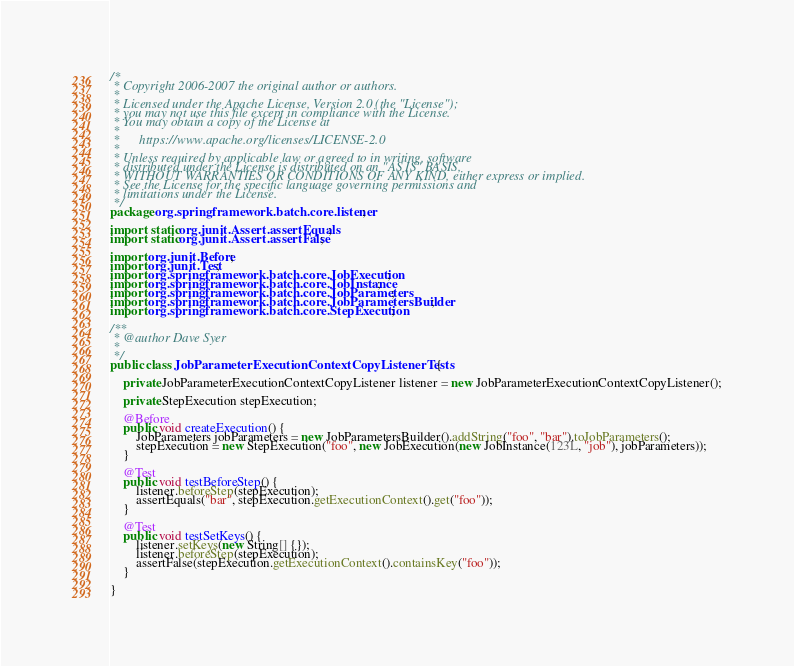<code> <loc_0><loc_0><loc_500><loc_500><_Java_>/*
 * Copyright 2006-2007 the original author or authors.
 *
 * Licensed under the Apache License, Version 2.0 (the "License");
 * you may not use this file except in compliance with the License.
 * You may obtain a copy of the License at
 *
 *      https://www.apache.org/licenses/LICENSE-2.0
 *
 * Unless required by applicable law or agreed to in writing, software
 * distributed under the License is distributed on an "AS IS" BASIS,
 * WITHOUT WARRANTIES OR CONDITIONS OF ANY KIND, either express or implied.
 * See the License for the specific language governing permissions and
 * limitations under the License.
 */
package org.springframework.batch.core.listener;

import static org.junit.Assert.assertEquals;
import static org.junit.Assert.assertFalse;

import org.junit.Before;
import org.junit.Test;
import org.springframework.batch.core.JobExecution;
import org.springframework.batch.core.JobInstance;
import org.springframework.batch.core.JobParameters;
import org.springframework.batch.core.JobParametersBuilder;
import org.springframework.batch.core.StepExecution;

/**
 * @author Dave Syer
 *
 */
public class JobParameterExecutionContextCopyListenerTests {

	private JobParameterExecutionContextCopyListener listener = new JobParameterExecutionContextCopyListener();

	private StepExecution stepExecution;

	@Before
	public void createExecution() {
		JobParameters jobParameters = new JobParametersBuilder().addString("foo", "bar").toJobParameters();
		stepExecution = new StepExecution("foo", new JobExecution(new JobInstance(123L, "job"), jobParameters));
	}

	@Test
	public void testBeforeStep() {
		listener.beforeStep(stepExecution);
		assertEquals("bar", stepExecution.getExecutionContext().get("foo"));
	}

	@Test
	public void testSetKeys() {
		listener.setKeys(new String[] {});
		listener.beforeStep(stepExecution);
		assertFalse(stepExecution.getExecutionContext().containsKey("foo"));
	}

}
</code> 